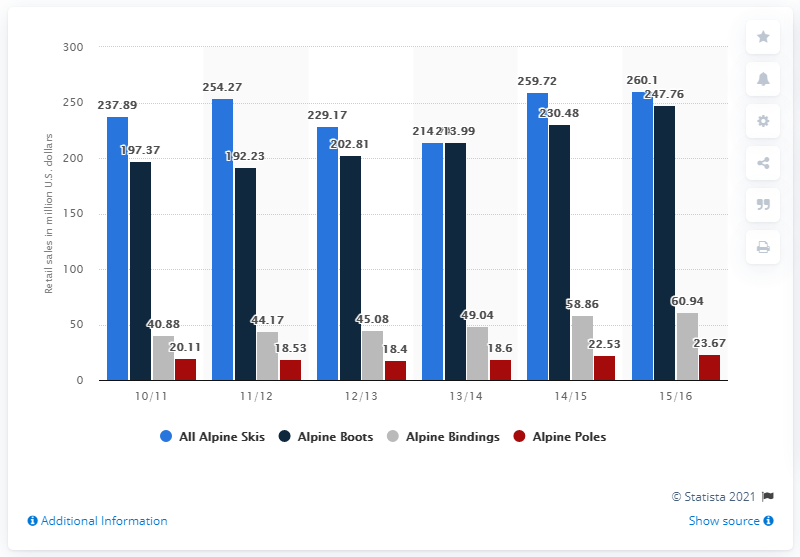Indicate a few pertinent items in this graphic. According to the data, retail sales of alpine skis in the 2015/16 season were valued at approximately 260.1 million U.S. dollars. 